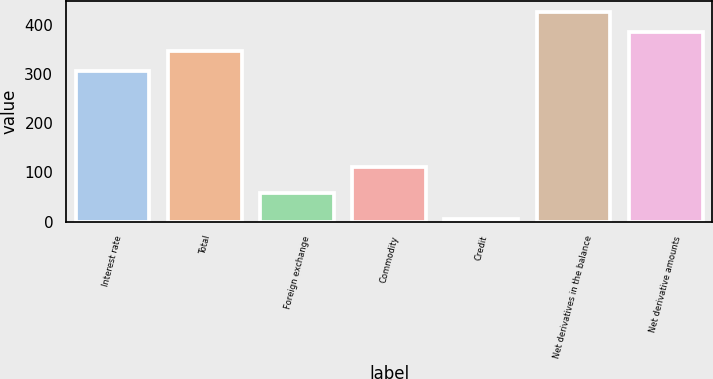<chart> <loc_0><loc_0><loc_500><loc_500><bar_chart><fcel>Interest rate<fcel>Total<fcel>Foreign exchange<fcel>Commodity<fcel>Credit<fcel>Net derivatives in the balance<fcel>Net derivative amounts<nl><fcel>306<fcel>346.2<fcel>59<fcel>112<fcel>5<fcel>426.6<fcel>386.4<nl></chart> 